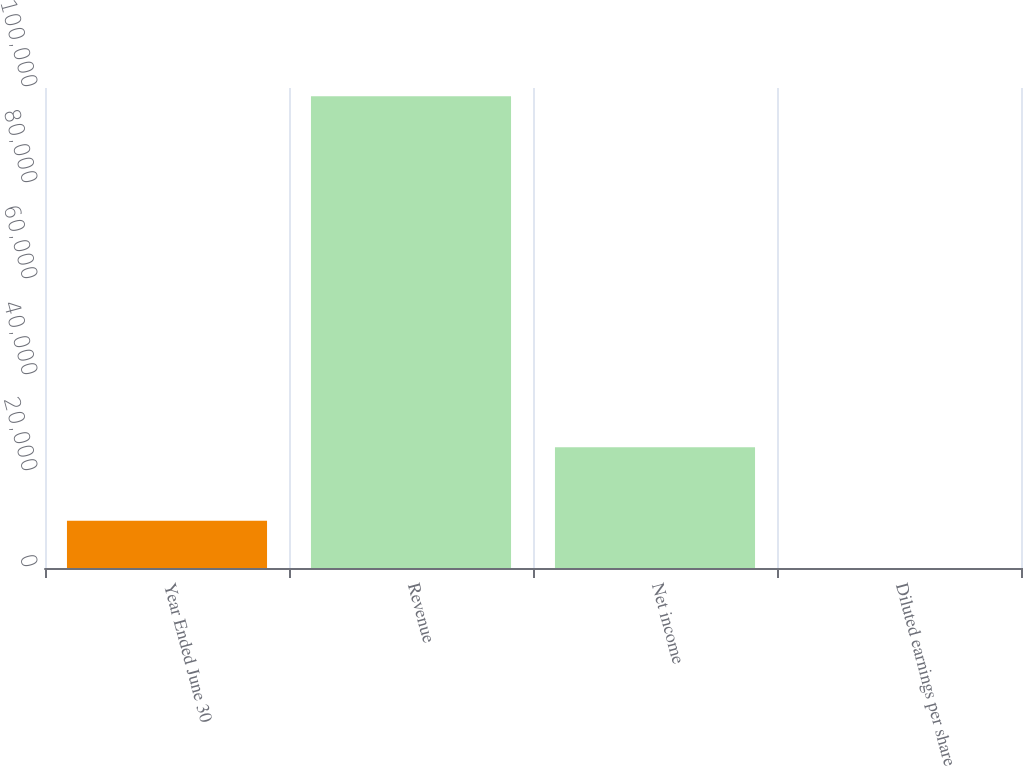<chart> <loc_0><loc_0><loc_500><loc_500><bar_chart><fcel>Year Ended June 30<fcel>Revenue<fcel>Net income<fcel>Diluted earnings per share<nl><fcel>9831.99<fcel>98291<fcel>25179<fcel>3.21<nl></chart> 